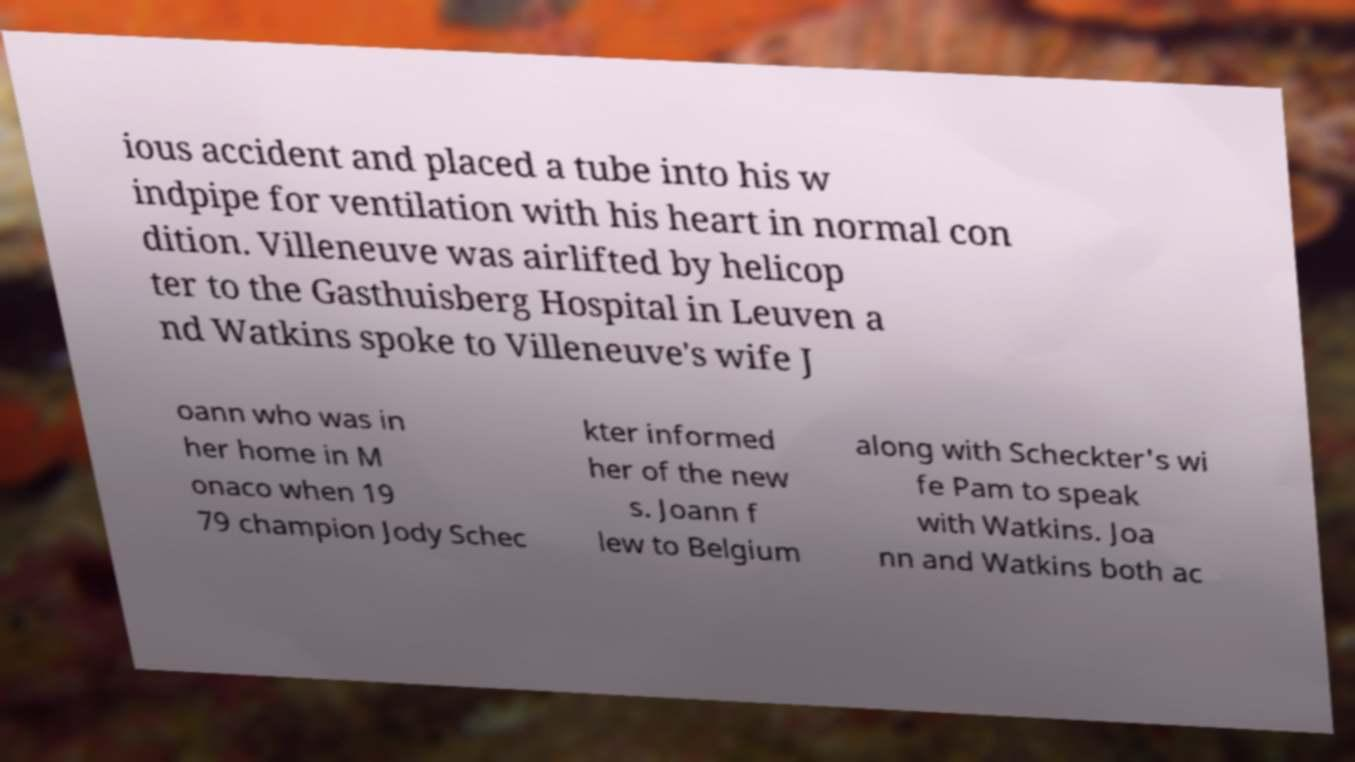Can you accurately transcribe the text from the provided image for me? ious accident and placed a tube into his w indpipe for ventilation with his heart in normal con dition. Villeneuve was airlifted by helicop ter to the Gasthuisberg Hospital in Leuven a nd Watkins spoke to Villeneuve's wife J oann who was in her home in M onaco when 19 79 champion Jody Schec kter informed her of the new s. Joann f lew to Belgium along with Scheckter's wi fe Pam to speak with Watkins. Joa nn and Watkins both ac 